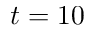Convert formula to latex. <formula><loc_0><loc_0><loc_500><loc_500>t = 1 0</formula> 